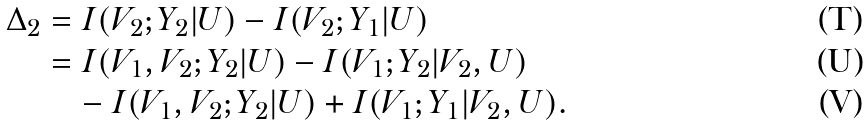<formula> <loc_0><loc_0><loc_500><loc_500>\Delta _ { 2 } & = I ( V _ { 2 } ; Y _ { 2 } | U ) - I ( V _ { 2 } ; Y _ { 1 } | U ) \\ & = I ( V _ { 1 } , V _ { 2 } ; Y _ { 2 } | U ) - I ( V _ { 1 } ; Y _ { 2 } | V _ { 2 } , U ) \\ & \quad - I ( V _ { 1 } , V _ { 2 } ; Y _ { 2 } | U ) + I ( V _ { 1 } ; Y _ { 1 } | V _ { 2 } , U ) .</formula> 